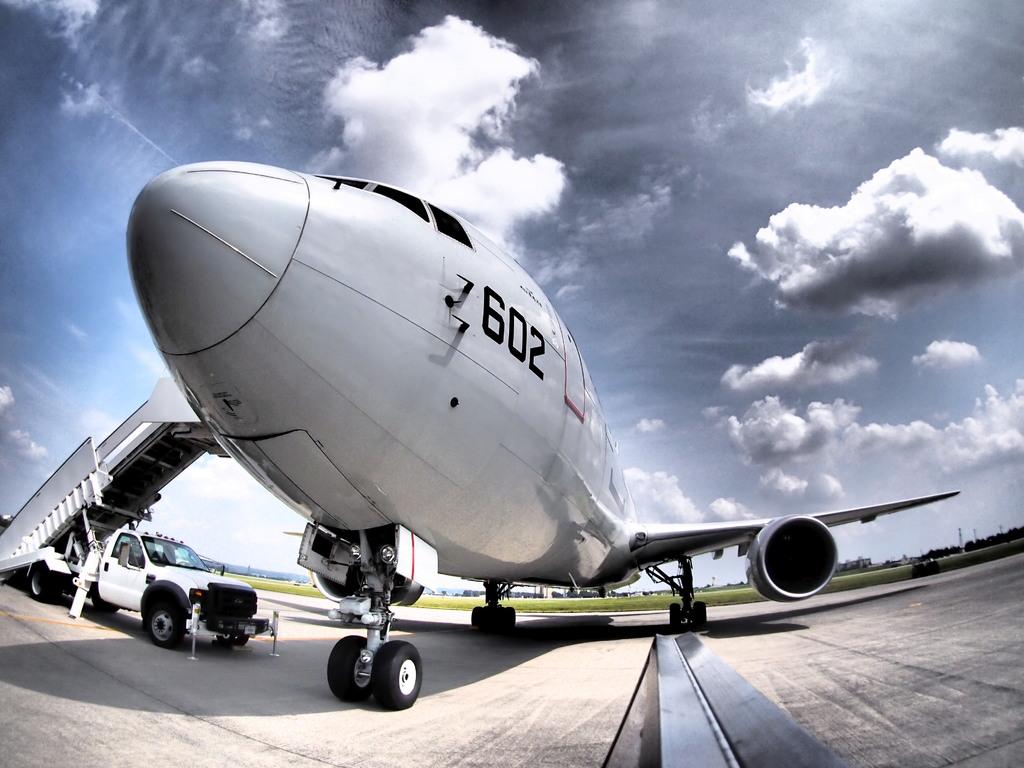What are the numbers displayed on the plane?
Provide a succinct answer. 602. 